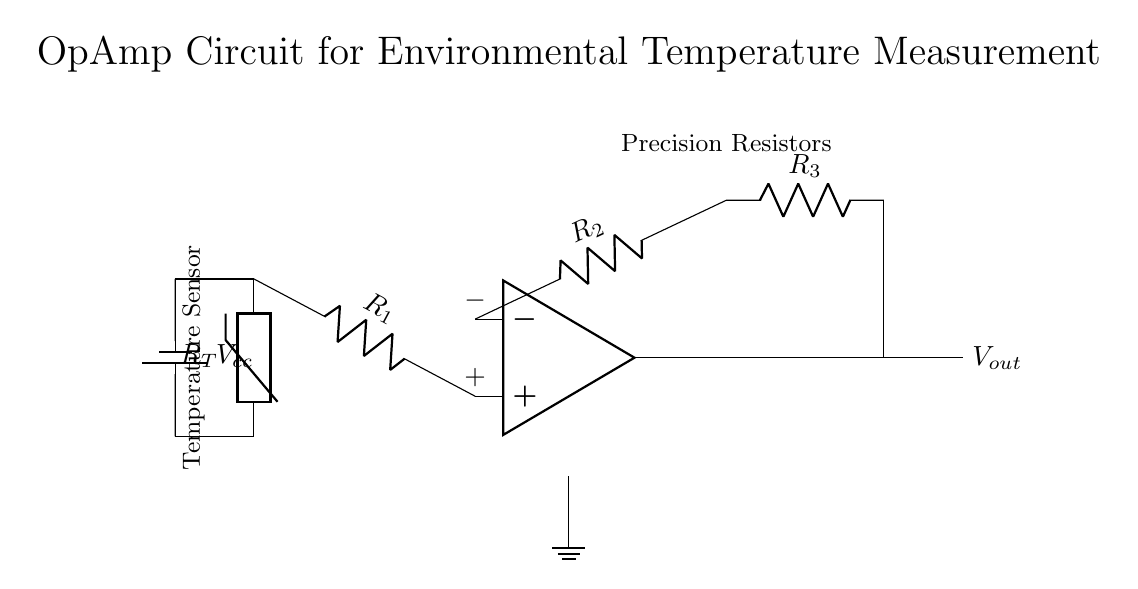What type of sensor is used in this circuit? The circuit uses a thermistor, which is indicated by the labeled component in the diagram. A thermistor is a type of temperature sensor that changes resistance with temperature.
Answer: Thermistor What is the function of the operational amplifier in this circuit? The operational amplifier amplifies the voltage difference between its input terminals, allowing for precise measurement of the temperature sensed by the thermistor. This amplification is crucial for accurately monitoring environmental temperature changes.
Answer: Amplification Which component supplies power to the circuit? The battery symbol, labeled as \( V_{cc} \), provides the necessary power supply for the circuit and is connected to the thermistor. The battery voltage ensures the operational amplifier and other components operate correctly.
Answer: Battery (\( V_{cc} \)) How many resistors are used in the feedback network of the operational amplifier? There are two resistors labeled \( R_2 \) and \( R_3 \) in the feedback network. They play a key role in determining the gain of the operational amplifier and thus affect the calibration of the temperature measurement.
Answer: Two (R2 and R3) What type of output can be expected from the operational amplifier? The output from the operational amplifier, labeled \( V_{out} \), is a voltage signal that represents the amplified temperature reading from the thermistor. The voltage level will vary depending on the resistance of the thermistor, which changes with temperature.
Answer: Voltage signal What role do the precision resistors play in this circuit? The precision resistors, indicated in the diagram, help in setting the gain of the operational amplifier accurately. By using resistors with a specific tolerance, the circuit can achieve better accuracy in temperature measurements.
Answer: Gain setting What is the significance of the ground connection in this circuit? The ground connection ensures a common reference point for all voltages in the circuit. This is essential for the proper operation of the operational amplifier and the overall functionality of the measurement system.
Answer: Common reference point 